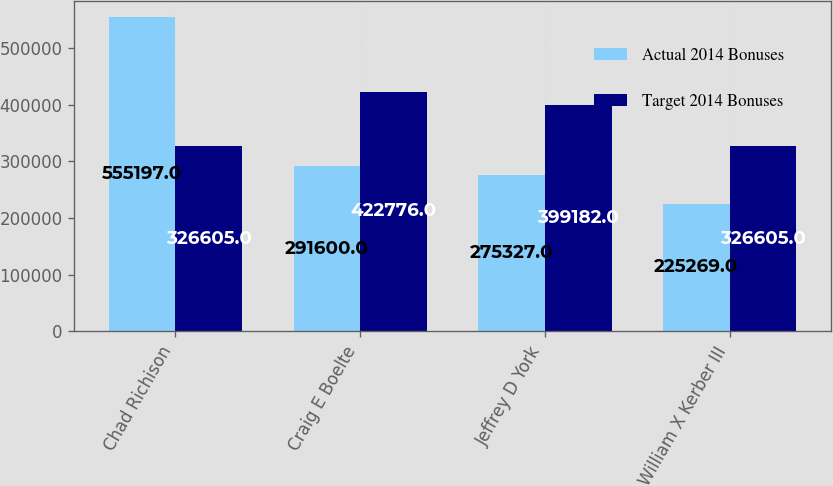Convert chart. <chart><loc_0><loc_0><loc_500><loc_500><stacked_bar_chart><ecel><fcel>Chad Richison<fcel>Craig E Boelte<fcel>Jeffrey D York<fcel>William X Kerber III<nl><fcel>Actual 2014 Bonuses<fcel>555197<fcel>291600<fcel>275327<fcel>225269<nl><fcel>Target 2014 Bonuses<fcel>326605<fcel>422776<fcel>399182<fcel>326605<nl></chart> 